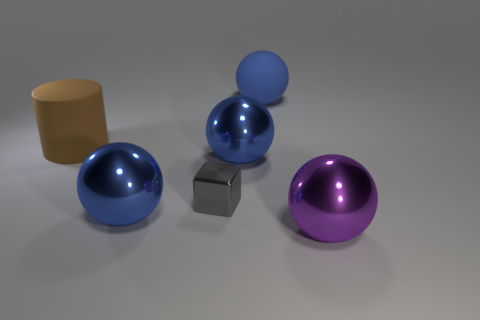How many blue balls must be subtracted to get 1 blue balls? 2 Subtract all purple spheres. How many spheres are left? 3 Subtract all purple balls. How many balls are left? 3 Add 3 big balls. How many objects exist? 9 Subtract 0 green cylinders. How many objects are left? 6 Subtract all cylinders. How many objects are left? 5 Subtract 3 balls. How many balls are left? 1 Subtract all yellow spheres. Subtract all brown cylinders. How many spheres are left? 4 Subtract all green cubes. How many purple balls are left? 1 Subtract all big metal objects. Subtract all big brown matte objects. How many objects are left? 2 